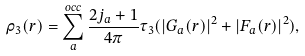Convert formula to latex. <formula><loc_0><loc_0><loc_500><loc_500>\rho _ { 3 } ( r ) = \sum _ { a } ^ { o c c } \frac { 2 j _ { a } + 1 } { 4 \pi } \tau _ { 3 } ( | G _ { a } ( r ) | ^ { 2 } + | F _ { a } ( r ) | ^ { 2 } ) ,</formula> 